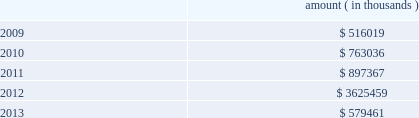Entergy corporation and subsidiaries notes to financial statements ( a ) consists of pollution control revenue bonds and environmental revenue bonds .
( b ) the bonds are secured by a series of collateral first mortgage bonds .
( c ) in december 2005 , entergy corporation sold 10 million equity units with a stated amount of $ 50 each .
An equity unit consisted of ( 1 ) a note , initially due february 2011 and initially bearing interest at an annual rate of 5.75% ( 5.75 % ) , and ( 2 ) a purchase contract that obligated the holder of the equity unit to purchase for $ 50 between 0.5705 and 0.7074 shares of entergy corporation common stock on or before february 17 , 2009 .
Entergy paid the holders quarterly contract adjustment payments of 1.875% ( 1.875 % ) per year on the stated amount of $ 50 per equity unit .
Under the terms of the purchase contracts , entergy attempted to remarket the notes in february 2009 but was unsuccessful , the note holders put the notes to entergy , entergy retired the notes , and entergy issued 6598000 shares of common stock in the settlement of the purchase contracts .
( d ) pursuant to the nuclear waste policy act of 1982 , entergy's nuclear owner/licensee subsidiaries have contracts with the doe for spent nuclear fuel disposal service .
The contracts include a one-time fee for generation prior to april 7 , 1983 .
Entergy arkansas is the only entergy company that generated electric power with nuclear fuel prior to that date and includes the one-time fee , plus accrued interest , in long-term ( e ) the fair value excludes lease obligations , long-term doe obligations , and the note payable to nypa , and includes debt due within one year .
It is determined using bid prices reported by dealer markets and by nationally recognized investment banking firms .
( f ) entergy gulf states louisiana remains primarily liable for all of the long-term debt issued by entergy gulf states , inc .
That was outstanding on december 31 , 2008 and 2007 .
Under a debt assumption agreement with entergy gulf states louisiana , entergy texas assumed approximately 46% ( 46 % ) of this long-term debt .
The annual long-term debt maturities ( excluding lease obligations ) for debt outstanding as of december 31 , 2008 , for the next five years are as follows : amount ( in thousands ) .
In november 2000 , entergy's non-utility nuclear business purchased the fitzpatrick and indian point 3 power plants in a seller-financed transaction .
Entergy issued notes to nypa with seven annual installments of approximately $ 108 million commencing one year from the date of the closing , and eight annual installments of $ 20 million commencing eight years from the date of the closing .
These notes do not have a stated interest rate , but have an implicit interest rate of 4.8% ( 4.8 % ) .
In accordance with the purchase agreement with nypa , the purchase of indian point 2 in 2001 resulted in entergy's non-utility nuclear business becoming liable to nypa for an additional $ 10 million per year for 10 years , beginning in september 2003 .
This liability was recorded upon the purchase of indian point 2 in september 2001 , and is included in the note payable to nypa balance above .
In july 2003 , a payment of $ 102 million was made prior to maturity on the note payable to nypa .
Under a provision in a letter of credit supporting these notes , if certain of the utility operating companies or system energy were to default on other indebtedness , entergy could be required to post collateral to support the letter of credit .
Covenants in the entergy corporation notes require it to maintain a consolidated debt ratio of 65% ( 65 % ) or less of its total capitalization .
If entergy's debt ratio exceeds this limit , or if entergy or certain of the utility operating companies default on other indebtedness or are in bankruptcy or insolvency proceedings , an acceleration of the notes' maturity dates may occur .
Entergy gulf states louisiana , entergy louisiana , entergy mississippi , entergy texas , and system energy have received ferc long-term financing orders authorizing long-term securities issuances .
Entergy arkansas has .
What value of debt in thousands will mature between 2009 and 2011? 
Computations: ((516019 + 763036) + 897367)
Answer: 2176422.0. 